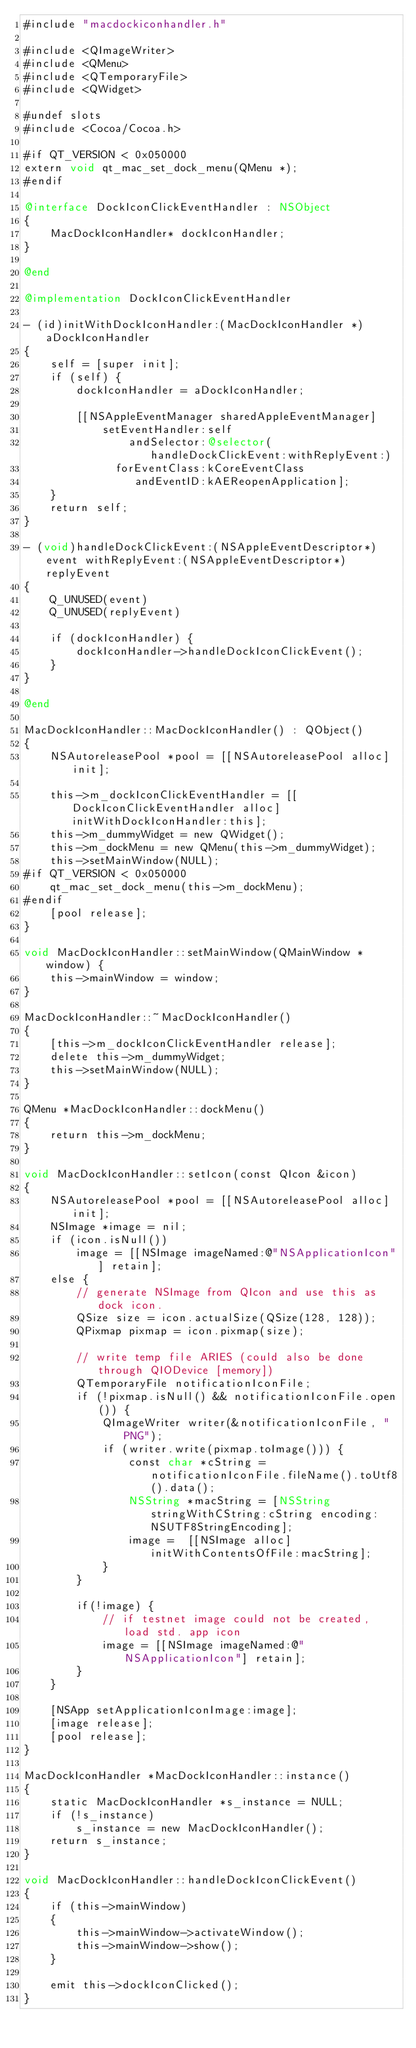<code> <loc_0><loc_0><loc_500><loc_500><_ObjectiveC_>#include "macdockiconhandler.h"

#include <QImageWriter>
#include <QMenu>
#include <QTemporaryFile>
#include <QWidget>

#undef slots
#include <Cocoa/Cocoa.h>

#if QT_VERSION < 0x050000
extern void qt_mac_set_dock_menu(QMenu *);
#endif

@interface DockIconClickEventHandler : NSObject
{
    MacDockIconHandler* dockIconHandler;
}

@end

@implementation DockIconClickEventHandler

- (id)initWithDockIconHandler:(MacDockIconHandler *)aDockIconHandler
{
    self = [super init];
    if (self) {
        dockIconHandler = aDockIconHandler;

        [[NSAppleEventManager sharedAppleEventManager]
            setEventHandler:self
                andSelector:@selector(handleDockClickEvent:withReplyEvent:)
              forEventClass:kCoreEventClass
                 andEventID:kAEReopenApplication];
    }
    return self;
}

- (void)handleDockClickEvent:(NSAppleEventDescriptor*)event withReplyEvent:(NSAppleEventDescriptor*)replyEvent
{
    Q_UNUSED(event)
    Q_UNUSED(replyEvent)

    if (dockIconHandler) {
        dockIconHandler->handleDockIconClickEvent();
    }
}

@end

MacDockIconHandler::MacDockIconHandler() : QObject()
{
    NSAutoreleasePool *pool = [[NSAutoreleasePool alloc] init];

    this->m_dockIconClickEventHandler = [[DockIconClickEventHandler alloc] initWithDockIconHandler:this];
    this->m_dummyWidget = new QWidget();
    this->m_dockMenu = new QMenu(this->m_dummyWidget);
    this->setMainWindow(NULL);
#if QT_VERSION < 0x050000
    qt_mac_set_dock_menu(this->m_dockMenu);
#endif
    [pool release];
}

void MacDockIconHandler::setMainWindow(QMainWindow *window) {
    this->mainWindow = window;
}

MacDockIconHandler::~MacDockIconHandler()
{
    [this->m_dockIconClickEventHandler release];
    delete this->m_dummyWidget;
    this->setMainWindow(NULL);
}

QMenu *MacDockIconHandler::dockMenu()
{
    return this->m_dockMenu;
}

void MacDockIconHandler::setIcon(const QIcon &icon)
{
    NSAutoreleasePool *pool = [[NSAutoreleasePool alloc] init];
    NSImage *image = nil;
    if (icon.isNull())
        image = [[NSImage imageNamed:@"NSApplicationIcon"] retain];
    else {
        // generate NSImage from QIcon and use this as dock icon.
        QSize size = icon.actualSize(QSize(128, 128));
        QPixmap pixmap = icon.pixmap(size);

        // write temp file ARIES (could also be done through QIODevice [memory])
        QTemporaryFile notificationIconFile;
        if (!pixmap.isNull() && notificationIconFile.open()) {
            QImageWriter writer(&notificationIconFile, "PNG");
            if (writer.write(pixmap.toImage())) {
                const char *cString = notificationIconFile.fileName().toUtf8().data();
                NSString *macString = [NSString stringWithCString:cString encoding:NSUTF8StringEncoding];
                image =  [[NSImage alloc] initWithContentsOfFile:macString];
            }
        }

        if(!image) {
            // if testnet image could not be created, load std. app icon
            image = [[NSImage imageNamed:@"NSApplicationIcon"] retain];
        }
    }

    [NSApp setApplicationIconImage:image];
    [image release];
    [pool release];
}

MacDockIconHandler *MacDockIconHandler::instance()
{
    static MacDockIconHandler *s_instance = NULL;
    if (!s_instance)
        s_instance = new MacDockIconHandler();
    return s_instance;
}

void MacDockIconHandler::handleDockIconClickEvent()
{
    if (this->mainWindow)
    {
        this->mainWindow->activateWindow();
        this->mainWindow->show();
    }

    emit this->dockIconClicked();
}
</code> 